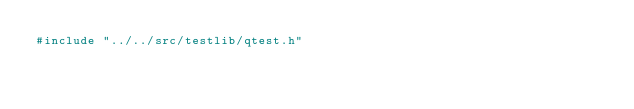Convert code to text. <code><loc_0><loc_0><loc_500><loc_500><_C_>#include "../../src/testlib/qtest.h"
</code> 